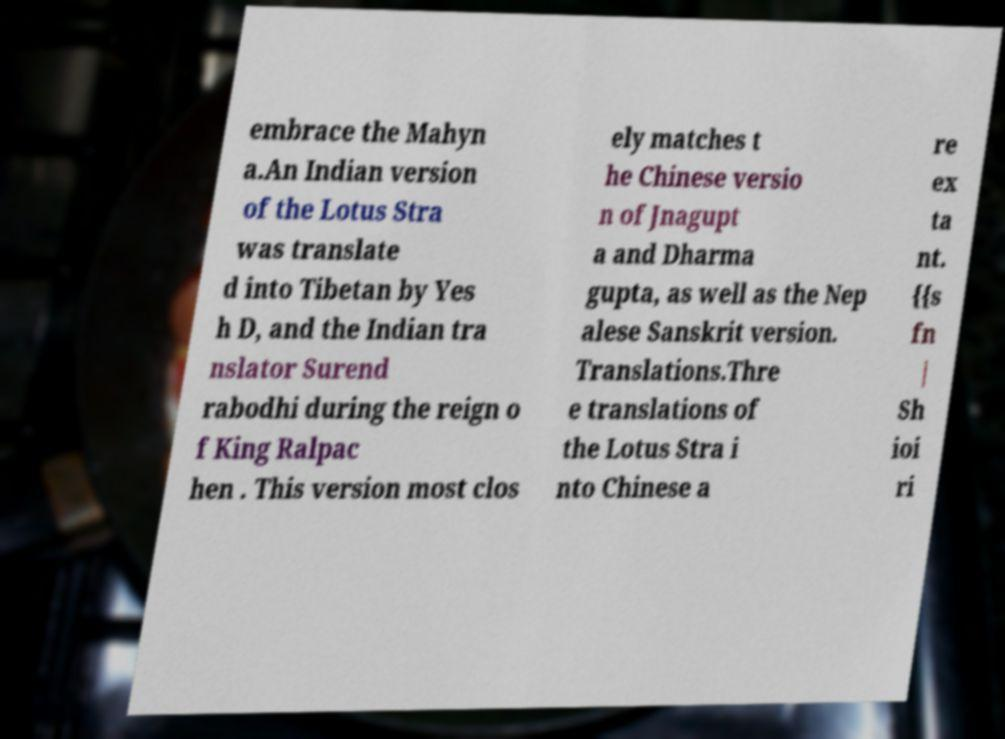Can you accurately transcribe the text from the provided image for me? embrace the Mahyn a.An Indian version of the Lotus Stra was translate d into Tibetan by Yes h D, and the Indian tra nslator Surend rabodhi during the reign o f King Ralpac hen . This version most clos ely matches t he Chinese versio n of Jnagupt a and Dharma gupta, as well as the Nep alese Sanskrit version. Translations.Thre e translations of the Lotus Stra i nto Chinese a re ex ta nt. {{s fn | Sh ioi ri 